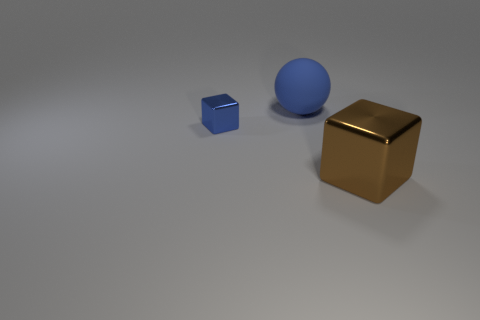What number of big rubber objects are on the right side of the blue object behind the small thing?
Make the answer very short. 0. Does the metal thing behind the big brown metal cube have the same color as the big thing that is in front of the blue ball?
Offer a terse response. No. There is a metallic thing to the right of the block left of the large cube; what is its shape?
Your answer should be very brief. Cube. The metal object that is on the left side of the large thing that is on the left side of the large cube that is to the right of the tiny blue cube is what shape?
Make the answer very short. Cube. Is the size of the blue block the same as the object to the right of the blue matte object?
Make the answer very short. No. Are the big thing that is left of the big brown object and the blue object in front of the large rubber object made of the same material?
Your answer should be compact. No. Are there an equal number of large brown objects in front of the brown block and blue matte things to the right of the large blue matte object?
Provide a succinct answer. Yes. What number of small shiny objects are the same color as the big matte object?
Your answer should be compact. 1. What is the material of the large ball that is the same color as the small object?
Ensure brevity in your answer.  Rubber. There is a blue object on the left side of the large blue sphere; does it have the same shape as the large object on the left side of the large brown thing?
Your answer should be compact. No. 